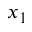Convert formula to latex. <formula><loc_0><loc_0><loc_500><loc_500>x _ { 1 }</formula> 